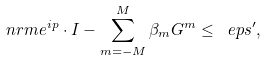<formula> <loc_0><loc_0><loc_500><loc_500>\ n r m { e ^ { i p } \cdot I - \sum _ { m = - M } ^ { M } \beta _ { m } G ^ { m } } \leq \ e p s ^ { \prime } ,</formula> 